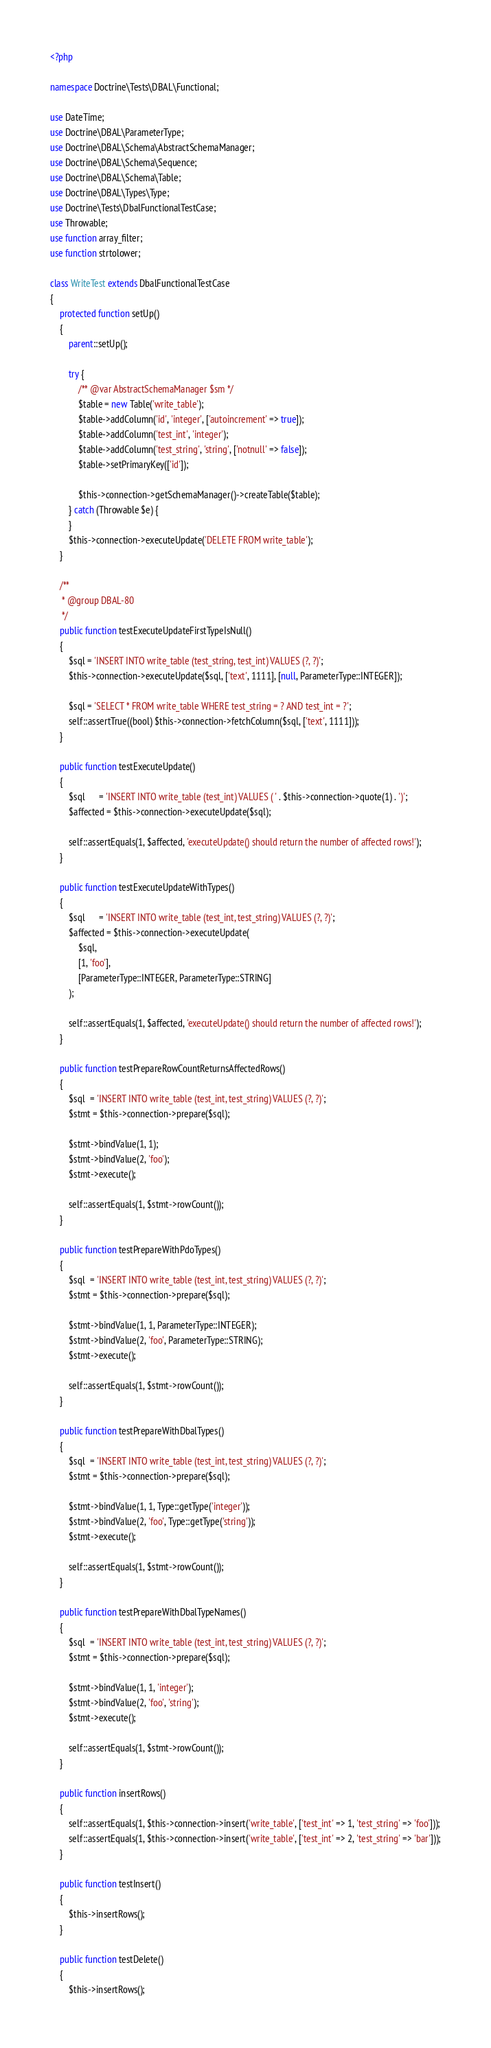Convert code to text. <code><loc_0><loc_0><loc_500><loc_500><_PHP_><?php

namespace Doctrine\Tests\DBAL\Functional;

use DateTime;
use Doctrine\DBAL\ParameterType;
use Doctrine\DBAL\Schema\AbstractSchemaManager;
use Doctrine\DBAL\Schema\Sequence;
use Doctrine\DBAL\Schema\Table;
use Doctrine\DBAL\Types\Type;
use Doctrine\Tests\DbalFunctionalTestCase;
use Throwable;
use function array_filter;
use function strtolower;

class WriteTest extends DbalFunctionalTestCase
{
    protected function setUp()
    {
        parent::setUp();

        try {
            /** @var AbstractSchemaManager $sm */
            $table = new Table('write_table');
            $table->addColumn('id', 'integer', ['autoincrement' => true]);
            $table->addColumn('test_int', 'integer');
            $table->addColumn('test_string', 'string', ['notnull' => false]);
            $table->setPrimaryKey(['id']);

            $this->connection->getSchemaManager()->createTable($table);
        } catch (Throwable $e) {
        }
        $this->connection->executeUpdate('DELETE FROM write_table');
    }

    /**
     * @group DBAL-80
     */
    public function testExecuteUpdateFirstTypeIsNull()
    {
        $sql = 'INSERT INTO write_table (test_string, test_int) VALUES (?, ?)';
        $this->connection->executeUpdate($sql, ['text', 1111], [null, ParameterType::INTEGER]);

        $sql = 'SELECT * FROM write_table WHERE test_string = ? AND test_int = ?';
        self::assertTrue((bool) $this->connection->fetchColumn($sql, ['text', 1111]));
    }

    public function testExecuteUpdate()
    {
        $sql      = 'INSERT INTO write_table (test_int) VALUES ( ' . $this->connection->quote(1) . ')';
        $affected = $this->connection->executeUpdate($sql);

        self::assertEquals(1, $affected, 'executeUpdate() should return the number of affected rows!');
    }

    public function testExecuteUpdateWithTypes()
    {
        $sql      = 'INSERT INTO write_table (test_int, test_string) VALUES (?, ?)';
        $affected = $this->connection->executeUpdate(
            $sql,
            [1, 'foo'],
            [ParameterType::INTEGER, ParameterType::STRING]
        );

        self::assertEquals(1, $affected, 'executeUpdate() should return the number of affected rows!');
    }

    public function testPrepareRowCountReturnsAffectedRows()
    {
        $sql  = 'INSERT INTO write_table (test_int, test_string) VALUES (?, ?)';
        $stmt = $this->connection->prepare($sql);

        $stmt->bindValue(1, 1);
        $stmt->bindValue(2, 'foo');
        $stmt->execute();

        self::assertEquals(1, $stmt->rowCount());
    }

    public function testPrepareWithPdoTypes()
    {
        $sql  = 'INSERT INTO write_table (test_int, test_string) VALUES (?, ?)';
        $stmt = $this->connection->prepare($sql);

        $stmt->bindValue(1, 1, ParameterType::INTEGER);
        $stmt->bindValue(2, 'foo', ParameterType::STRING);
        $stmt->execute();

        self::assertEquals(1, $stmt->rowCount());
    }

    public function testPrepareWithDbalTypes()
    {
        $sql  = 'INSERT INTO write_table (test_int, test_string) VALUES (?, ?)';
        $stmt = $this->connection->prepare($sql);

        $stmt->bindValue(1, 1, Type::getType('integer'));
        $stmt->bindValue(2, 'foo', Type::getType('string'));
        $stmt->execute();

        self::assertEquals(1, $stmt->rowCount());
    }

    public function testPrepareWithDbalTypeNames()
    {
        $sql  = 'INSERT INTO write_table (test_int, test_string) VALUES (?, ?)';
        $stmt = $this->connection->prepare($sql);

        $stmt->bindValue(1, 1, 'integer');
        $stmt->bindValue(2, 'foo', 'string');
        $stmt->execute();

        self::assertEquals(1, $stmt->rowCount());
    }

    public function insertRows()
    {
        self::assertEquals(1, $this->connection->insert('write_table', ['test_int' => 1, 'test_string' => 'foo']));
        self::assertEquals(1, $this->connection->insert('write_table', ['test_int' => 2, 'test_string' => 'bar']));
    }

    public function testInsert()
    {
        $this->insertRows();
    }

    public function testDelete()
    {
        $this->insertRows();
</code> 